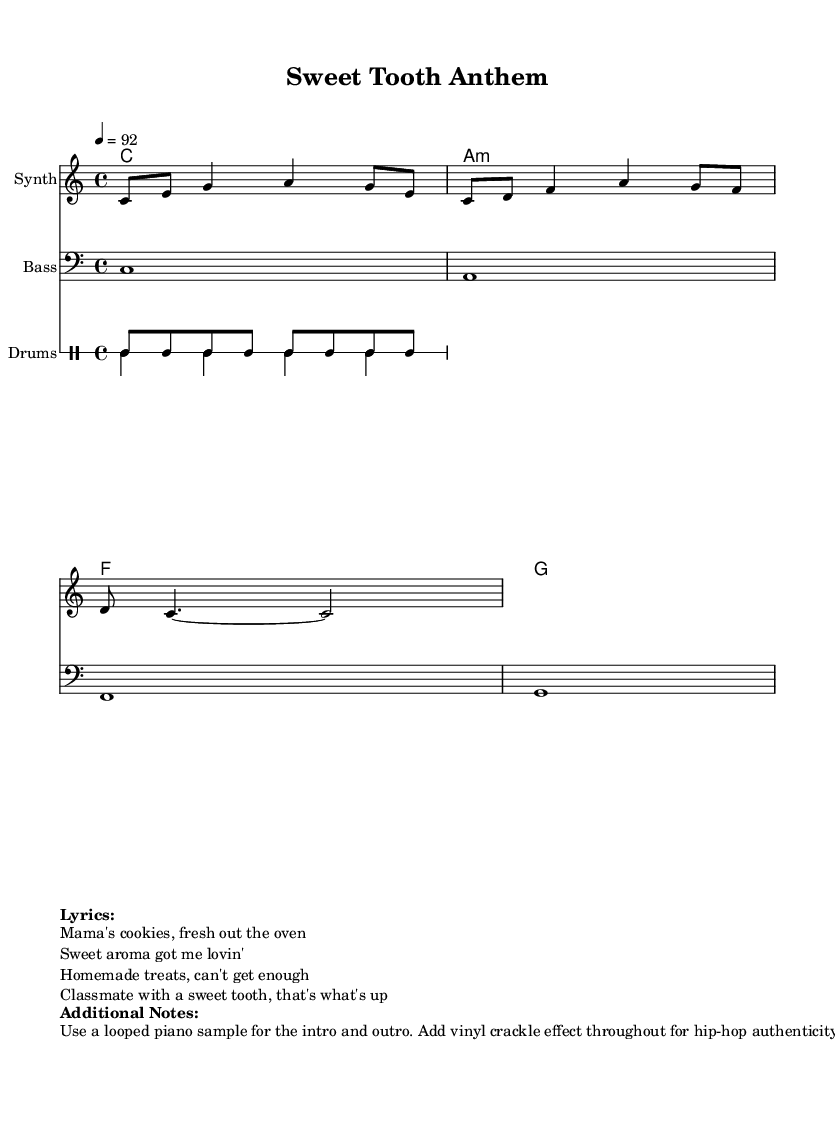What is the key signature of this music? The key signature is indicated at the beginning of the score and shows no sharps or flats, indicating a C major key.
Answer: C major What is the time signature of the piece? The time signature is shown at the beginning of the score immediately after the key signature, revealing that it follows a 4/4 pattern.
Answer: 4/4 What is the tempo of the song? The tempo is listed in beats per minute, which is 92 in this score, indicating the speed at which the music should be played.
Answer: 92 What instruments are featured in the score? The instruments can be identified by their labels at the beginning of their respective staff lines, which include 'Synth', 'Bass', and 'Drums'.
Answer: Synth, Bass, Drums How many measures are in the melody section? By visually counting the bars in the melody staff, there are 3 full measures displayed in the notation shown.
Answer: 3 What effect is suggested to be added throughout the piece? The additional notes mention a vinyl crackle effect, which is a common element in hip-hop production, enhancing the authenticity of the track.
Answer: Vinyl crackle What lyrics are repeated in the song? The lyrics mention "Mama's cookies, fresh out the oven", which indicates the theme of homemade desserts throughout the piece.
Answer: Mama's cookies 